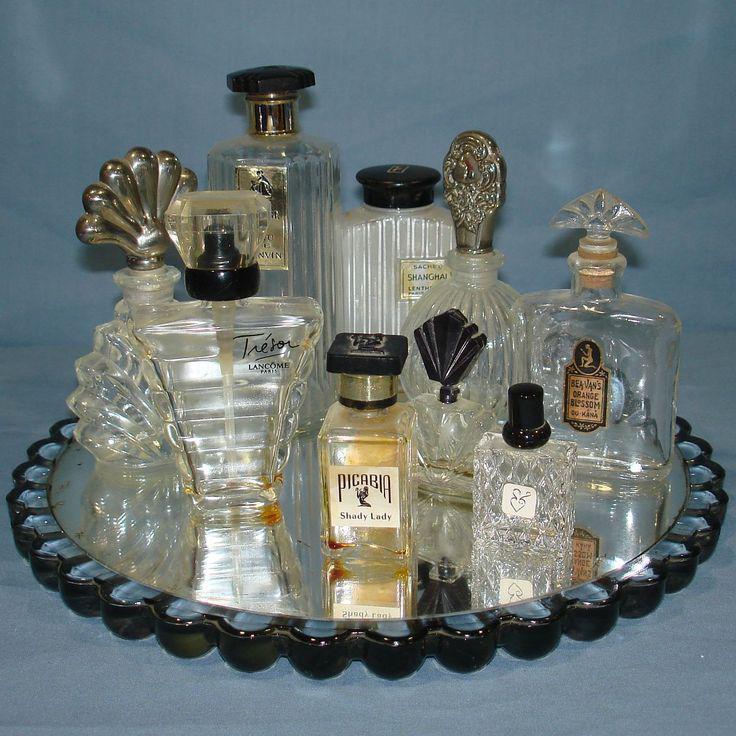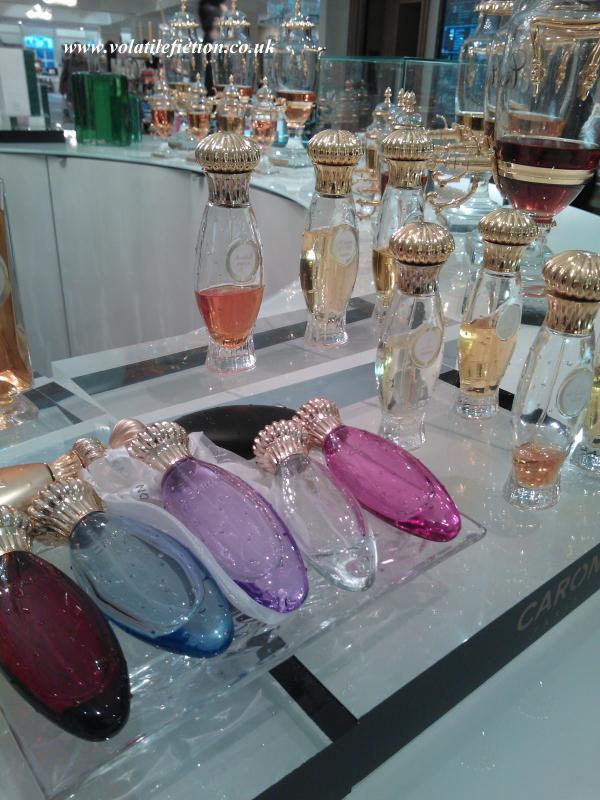The first image is the image on the left, the second image is the image on the right. For the images shown, is this caption "A website address is visible in both images." true? Answer yes or no. Yes. 